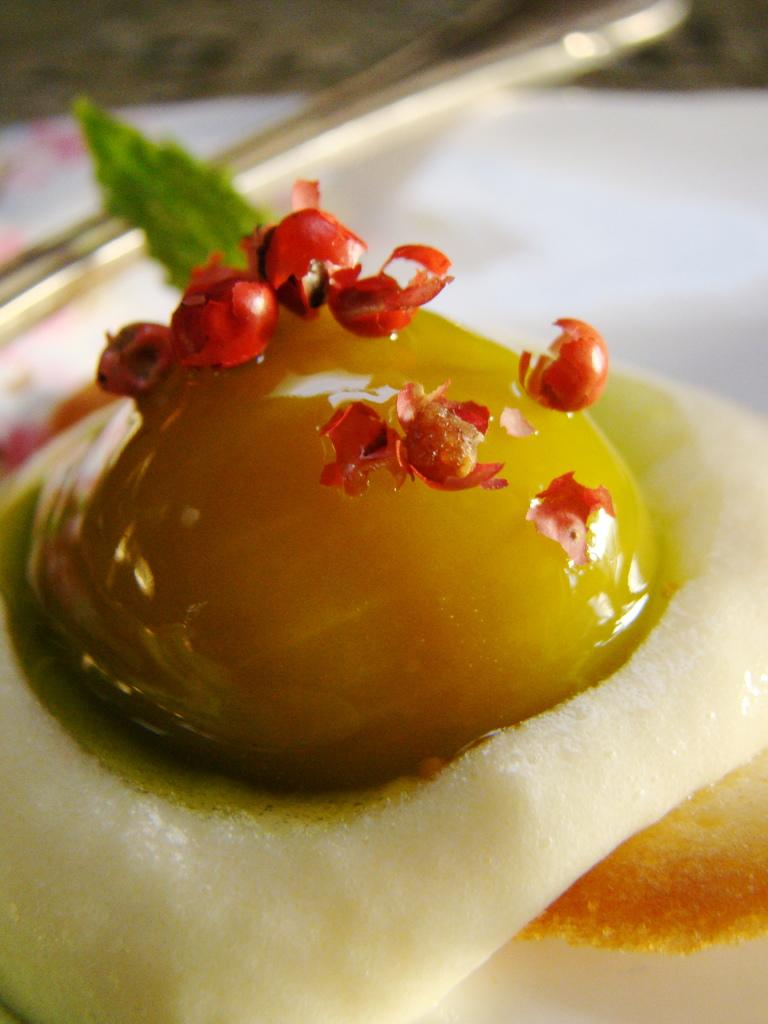What type of food can be seen in the image? There is a dessert in the image. What utensil is present with the dessert? A spoon is visible in the image. Where are the dessert and spoon located? The dessert and spoon are placed on a serving plate. What type of structure can be seen in the background of the image? There is no structure visible in the image; it only shows a dessert and a spoon on a serving plate. 